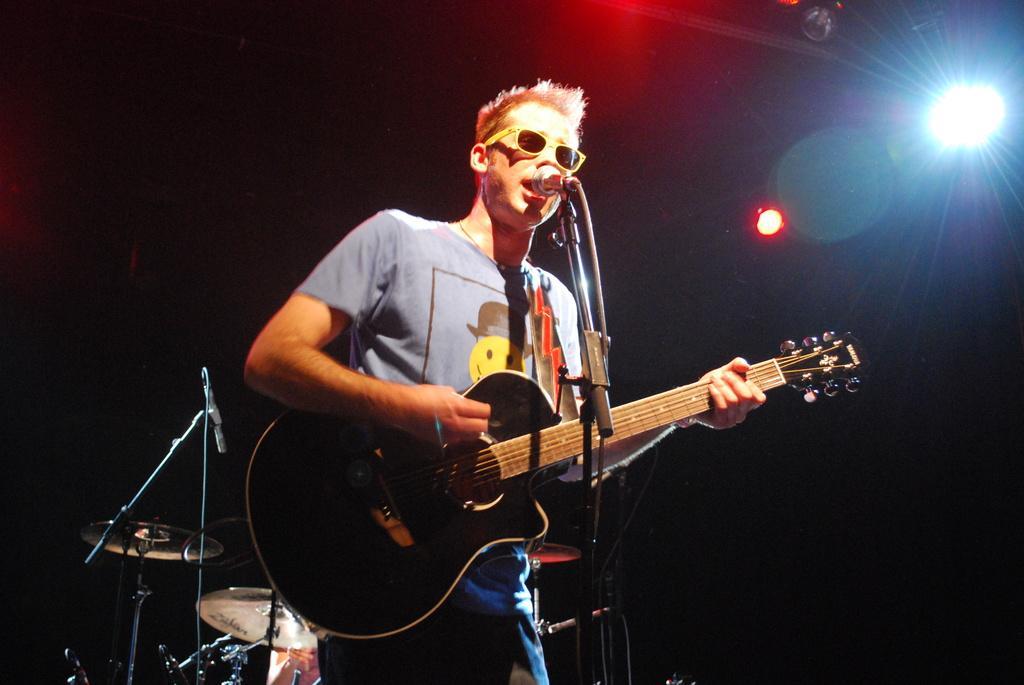How would you summarize this image in a sentence or two? In this picture , it is a music concert a person is wearing blue color shirt who is singing a song , he is wearing spectacles, there is a mike in front of him , he is holding a black color guitar with his hands behind him there are few drums, in the background there are few lights and it is a black color background. 